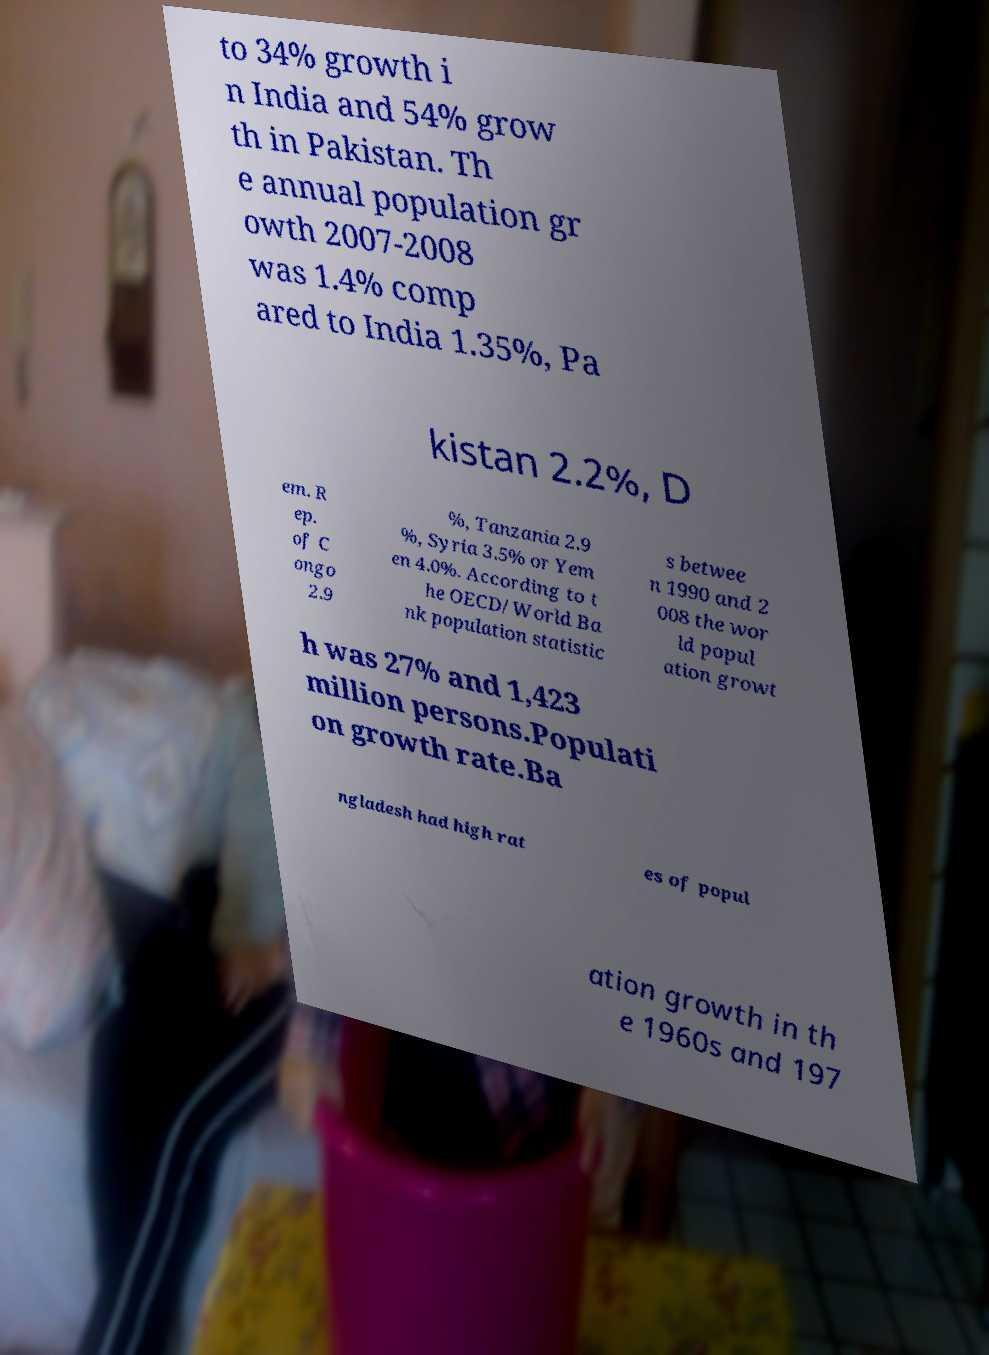There's text embedded in this image that I need extracted. Can you transcribe it verbatim? to 34% growth i n India and 54% grow th in Pakistan. Th e annual population gr owth 2007-2008 was 1.4% comp ared to India 1.35%, Pa kistan 2.2%, D em. R ep. of C ongo 2.9 %, Tanzania 2.9 %, Syria 3.5% or Yem en 4.0%. According to t he OECD/World Ba nk population statistic s betwee n 1990 and 2 008 the wor ld popul ation growt h was 27% and 1,423 million persons.Populati on growth rate.Ba ngladesh had high rat es of popul ation growth in th e 1960s and 197 